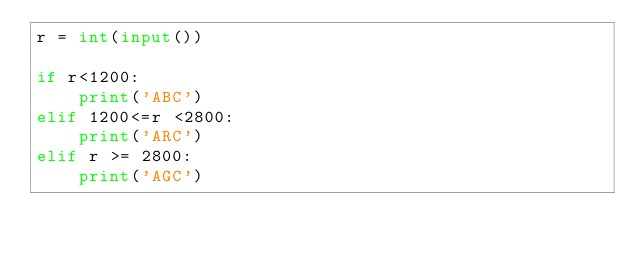Convert code to text. <code><loc_0><loc_0><loc_500><loc_500><_Python_>r = int(input())

if r<1200:
    print('ABC')
elif 1200<=r <2800:
    print('ARC')
elif r >= 2800:
    print('AGC')
</code> 